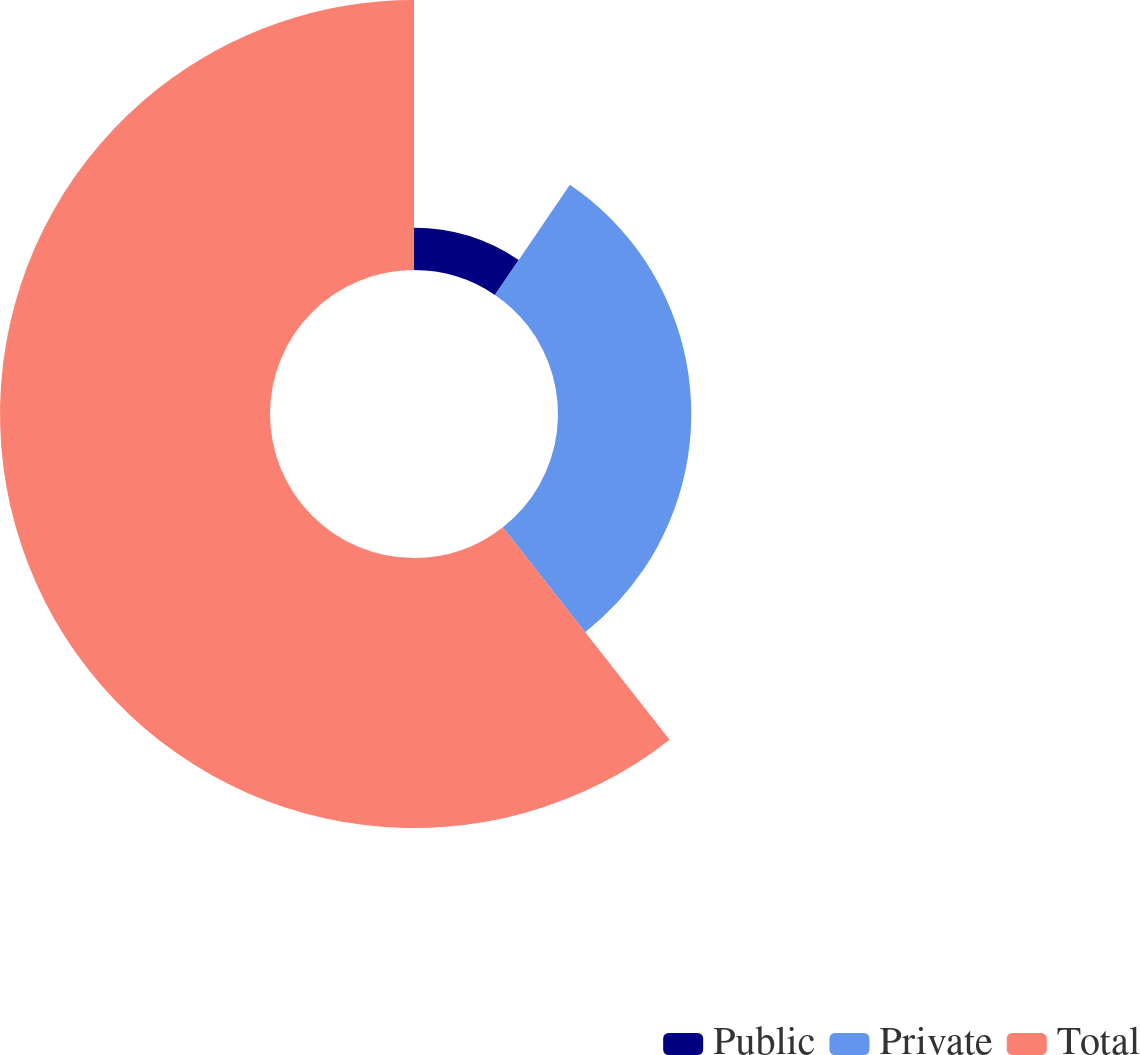Convert chart to OTSL. <chart><loc_0><loc_0><loc_500><loc_500><pie_chart><fcel>Public<fcel>Private<fcel>Total<nl><fcel>9.5%<fcel>29.91%<fcel>60.59%<nl></chart> 